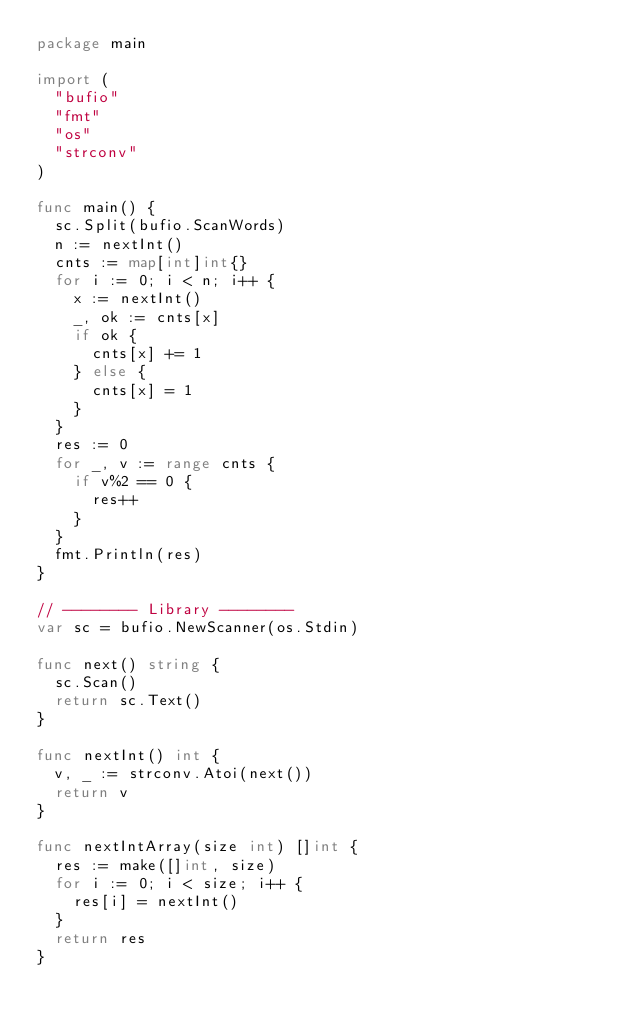<code> <loc_0><loc_0><loc_500><loc_500><_Go_>package main

import (
	"bufio"
	"fmt"
	"os"
	"strconv"
)

func main() {
	sc.Split(bufio.ScanWords)
	n := nextInt()
	cnts := map[int]int{}
	for i := 0; i < n; i++ {
		x := nextInt()
		_, ok := cnts[x]
		if ok {
			cnts[x] += 1
		} else {
			cnts[x] = 1
		}
	}
	res := 0
	for _, v := range cnts {
		if v%2 == 0 {
			res++
		}
	}
	fmt.Println(res)
}

// -------- Library --------
var sc = bufio.NewScanner(os.Stdin)

func next() string {
	sc.Scan()
	return sc.Text()
}

func nextInt() int {
	v, _ := strconv.Atoi(next())
	return v
}

func nextIntArray(size int) []int {
	res := make([]int, size)
	for i := 0; i < size; i++ {
		res[i] = nextInt()
	}
	return res
}
</code> 